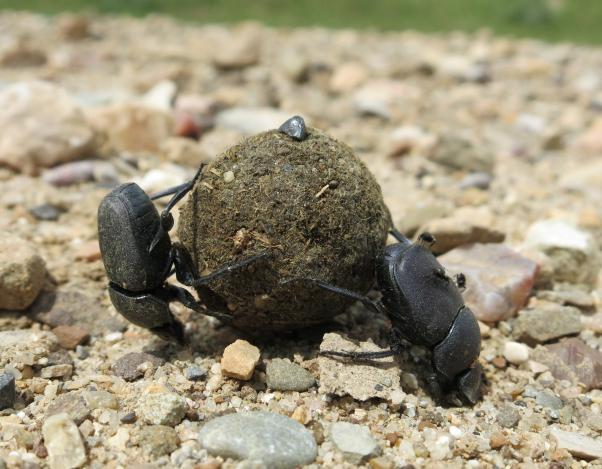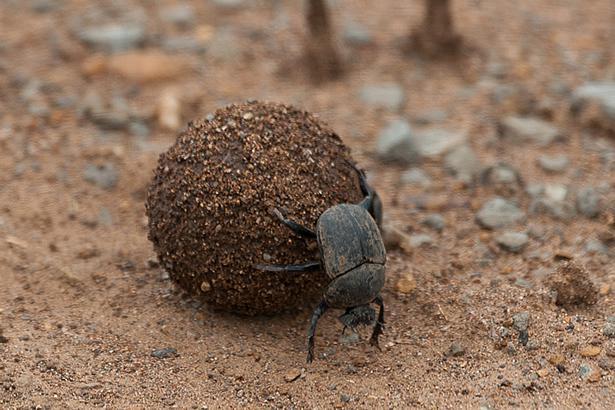The first image is the image on the left, the second image is the image on the right. Analyze the images presented: Is the assertion "Two beetles climb on a clod of dirt in the image on the left." valid? Answer yes or no. Yes. The first image is the image on the left, the second image is the image on the right. For the images displayed, is the sentence "A beetle with a shiny textured back is alone in an image without a dung ball shape." factually correct? Answer yes or no. No. 